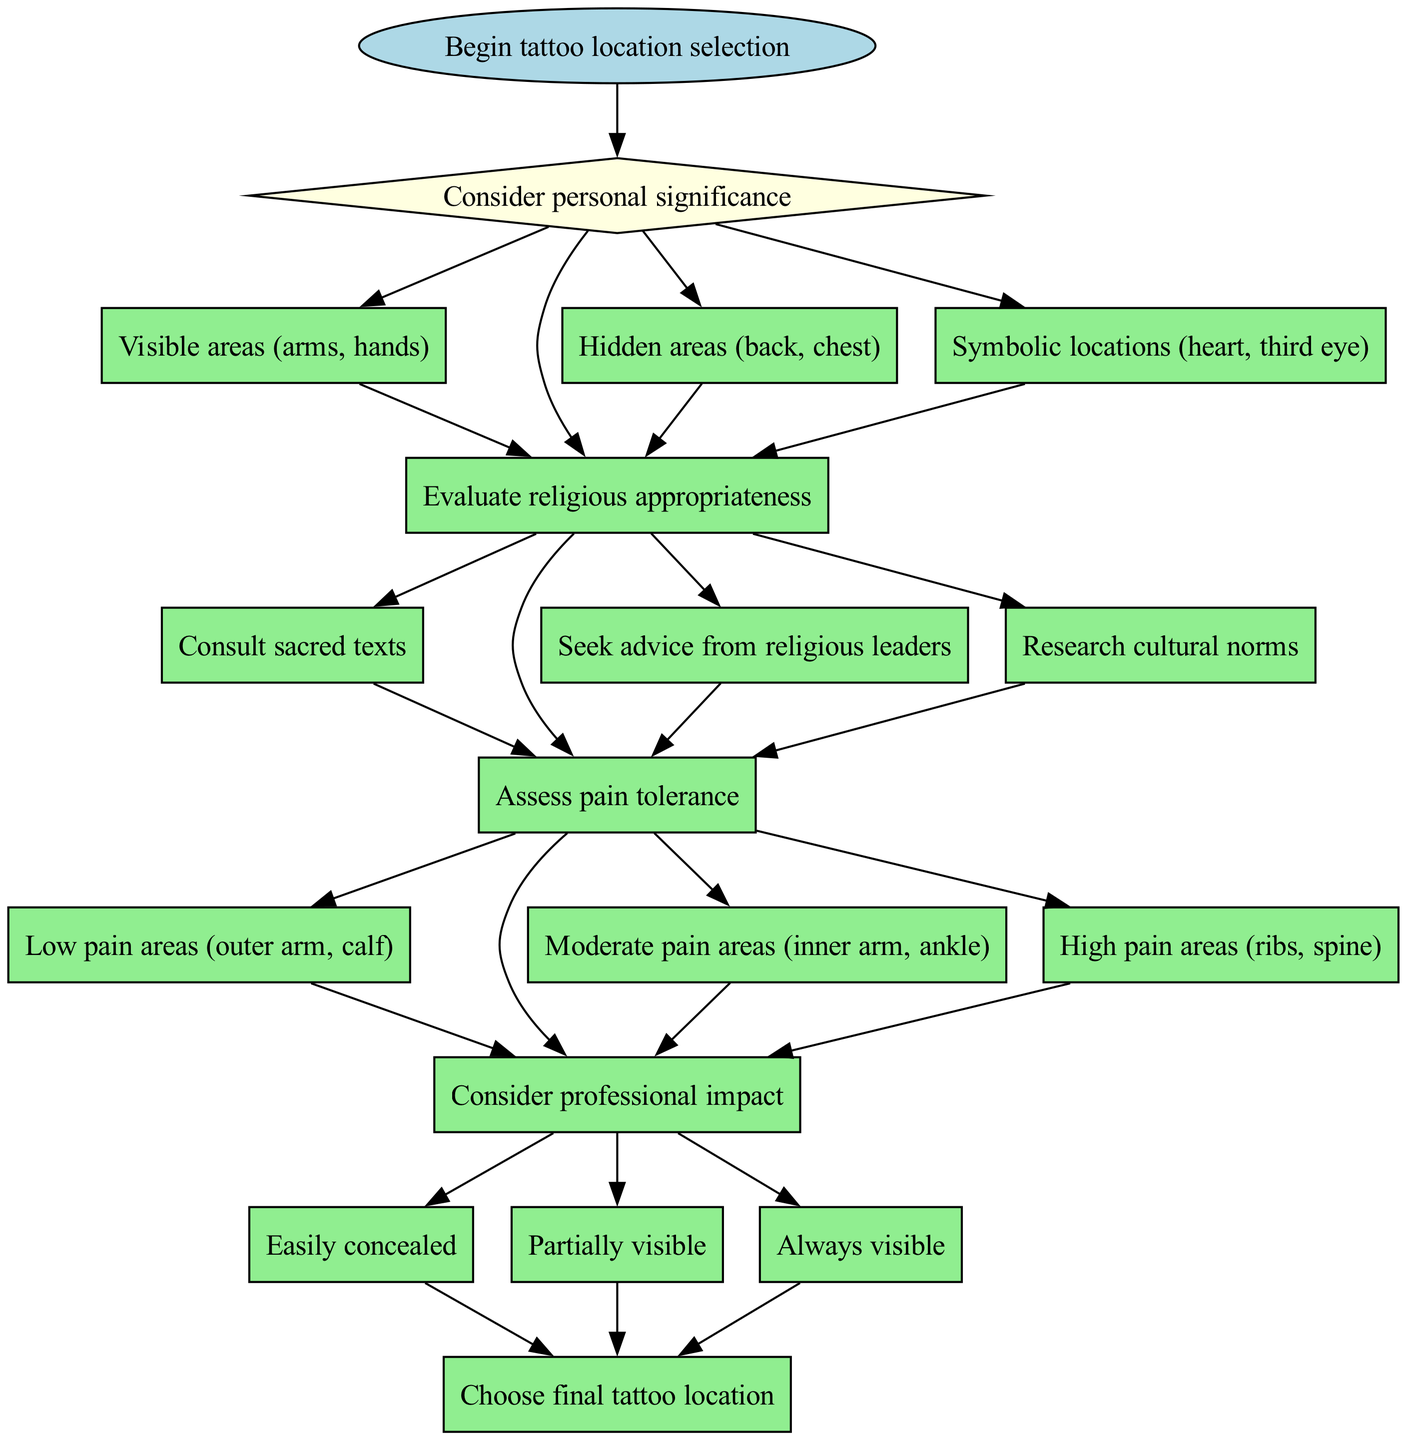What is the first question presented in the diagram? The diagram begins with a start node connected to the first decision node. The first question is directly stated in that decision node.
Answer: Consider personal significance How many decision points are there in the diagram? The diagram lists out four decision points that require choices before arriving at the end node. This can be counted by reviewing the decision nodes in the flow.
Answer: 4 What options are listed under the question about personal significance? The options are connected directly to the question about personal significance, and they can be found in the respective nodes branching out from that decision node.
Answer: Visible areas (arms, hands), Hidden areas (back, chest), Symbolic locations (heart, third eye) Which decision node connects to the last option of the second decision point? The second decision point asks about evaluating religious appropriateness. The last option is "Research cultural norms", which can be identified by tracing the edges leading from that decision node.
Answer: Assess pain tolerance What is the connection structure from the "Moderate pain areas" option? The "Moderate pain areas" option is connected to the next decision node by an edge, indicating that selecting this option leads directly to assessing the professional impact, forming a linear progression through the diagram.
Answer: Connects to assess professional impact If "Always visible" is chosen, what would be the next step in the flow? The "Always visible" option is one of the choices under evaluating professional impact. Selecting this leads directly to the end node of the diagram, concluding the process entirely.
Answer: Choose final tattoo location 